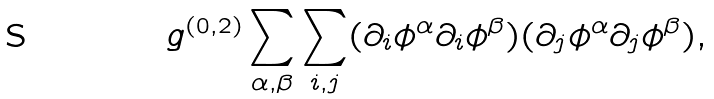Convert formula to latex. <formula><loc_0><loc_0><loc_500><loc_500>g ^ { ( 0 , 2 ) } \sum _ { \alpha , \beta } \sum _ { i , j } ( \partial _ { i } \phi ^ { \alpha } \partial _ { i } \phi ^ { \beta } ) ( \partial _ { j } \phi ^ { \alpha } \partial _ { j } \phi ^ { \beta } ) ,</formula> 